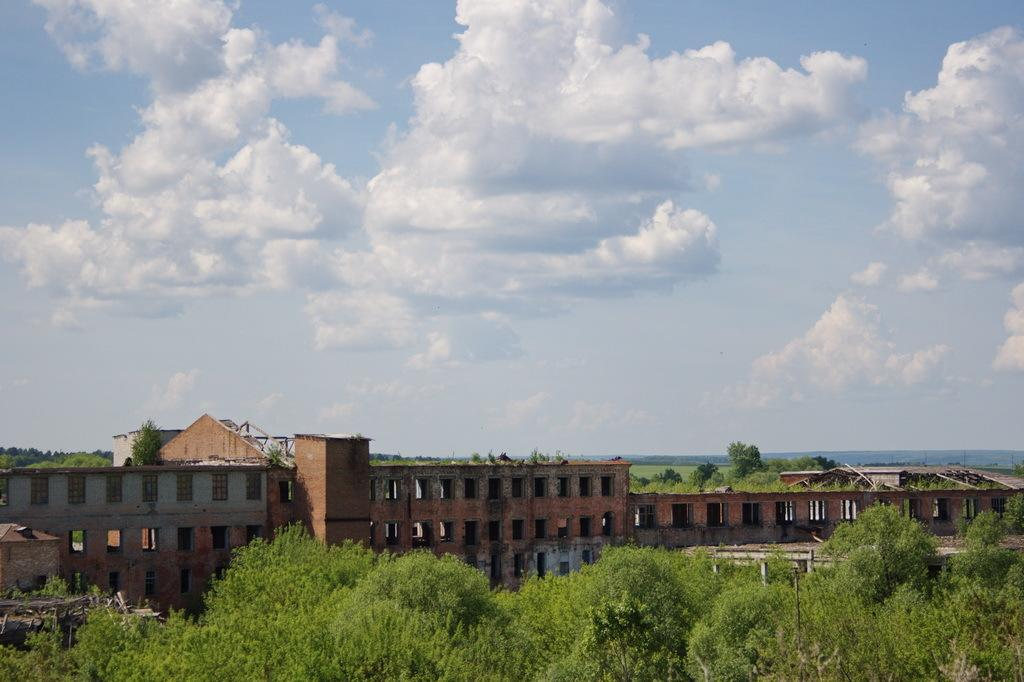What can be seen in the foreground of the image? There are trees and buildings in the foreground of the image. What is visible in the background of the image? The sky is visible in the image. What can be observed in the sky? There are clouds in the sky. What shape is the brain in the image? There is no brain present in the image. 